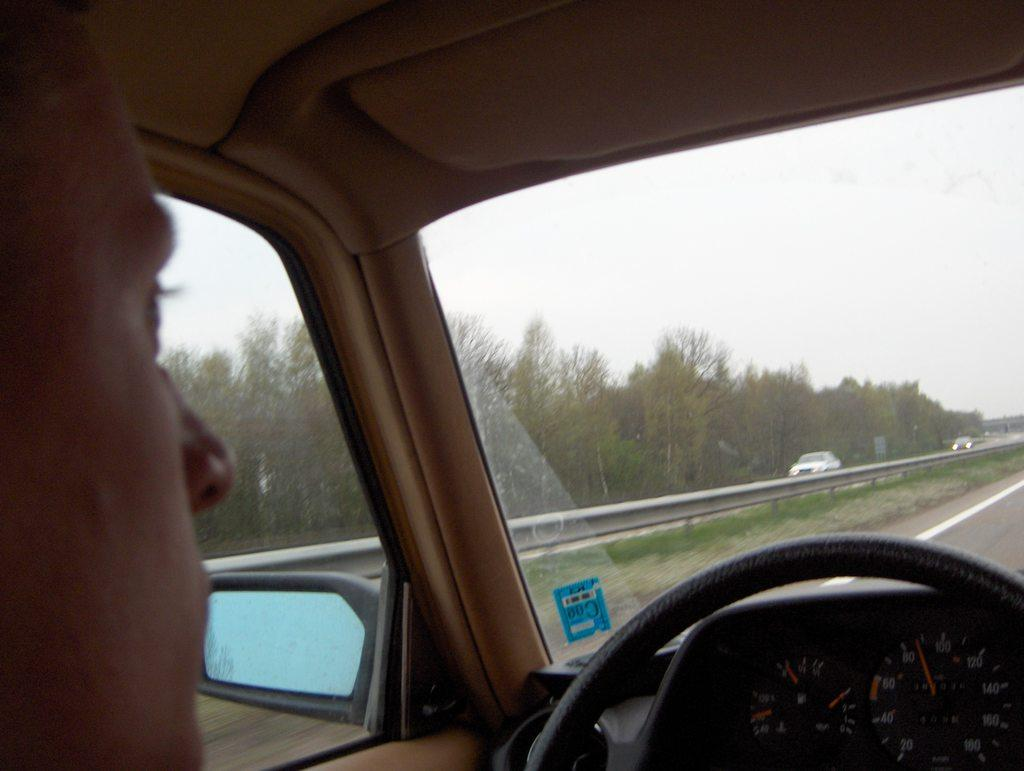What is the person in the image doing? There is a person driving a car in the image. What can be seen in the background of the image? There is a road visible in the image, with trees alongside the road. What type of barrier is present in the image? There is a metal railing in the image. How many other cars can be seen in the image? There are other cars visible in the image. What type of straw is being used to design the hose in the image? There is no straw or hose present in the image; it features a person driving a car on a road with trees and other cars. 